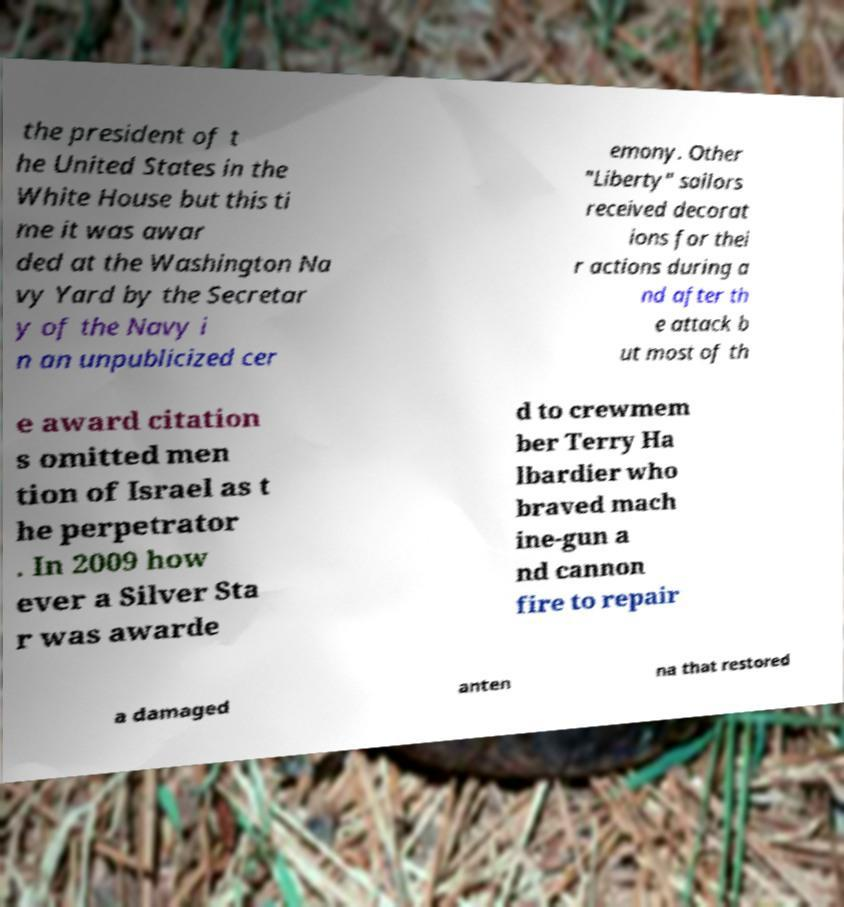For documentation purposes, I need the text within this image transcribed. Could you provide that? the president of t he United States in the White House but this ti me it was awar ded at the Washington Na vy Yard by the Secretar y of the Navy i n an unpublicized cer emony. Other "Liberty" sailors received decorat ions for thei r actions during a nd after th e attack b ut most of th e award citation s omitted men tion of Israel as t he perpetrator . In 2009 how ever a Silver Sta r was awarde d to crewmem ber Terry Ha lbardier who braved mach ine-gun a nd cannon fire to repair a damaged anten na that restored 